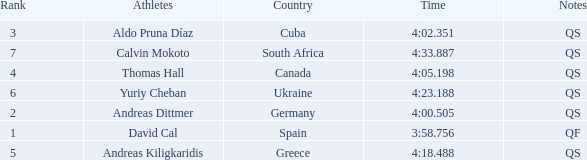What are the notes for the athlete from Spain? QF. 